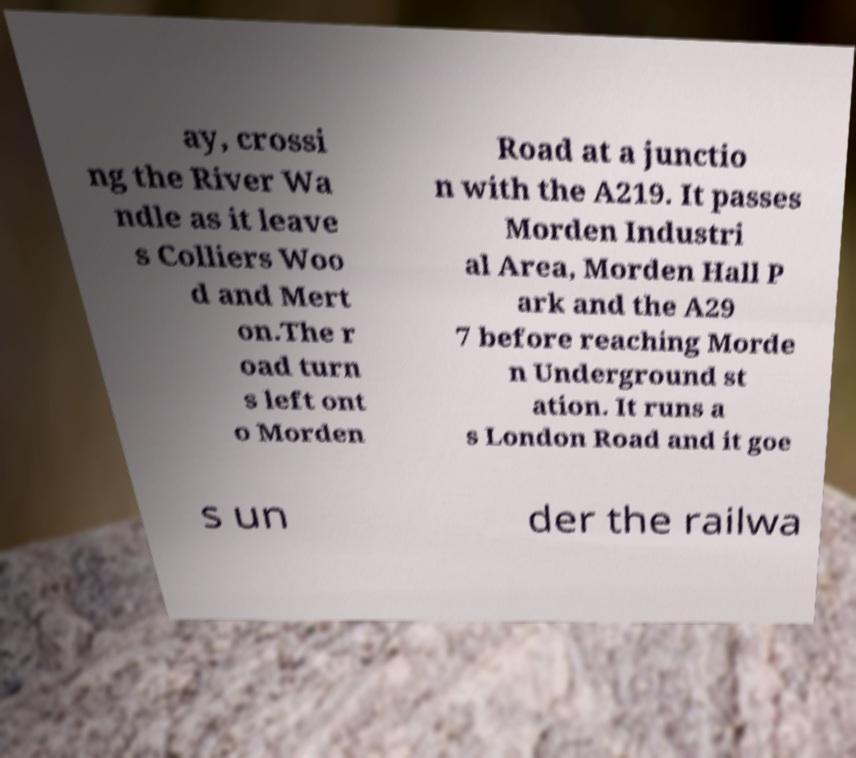Could you assist in decoding the text presented in this image and type it out clearly? ay, crossi ng the River Wa ndle as it leave s Colliers Woo d and Mert on.The r oad turn s left ont o Morden Road at a junctio n with the A219. It passes Morden Industri al Area, Morden Hall P ark and the A29 7 before reaching Morde n Underground st ation. It runs a s London Road and it goe s un der the railwa 